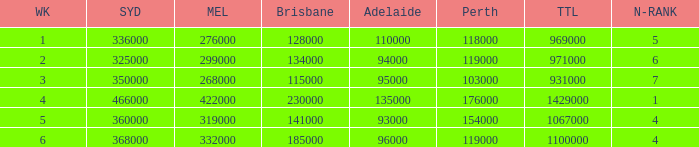What was the total rating on week 3?  931000.0. 